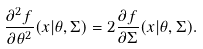<formula> <loc_0><loc_0><loc_500><loc_500>\frac { \partial ^ { 2 } { f } } { \partial { \theta } ^ { 2 } } ( x | \theta , \Sigma ) = 2 \frac { \partial { f } } { \partial { \Sigma } } ( x | \theta , \Sigma ) .</formula> 